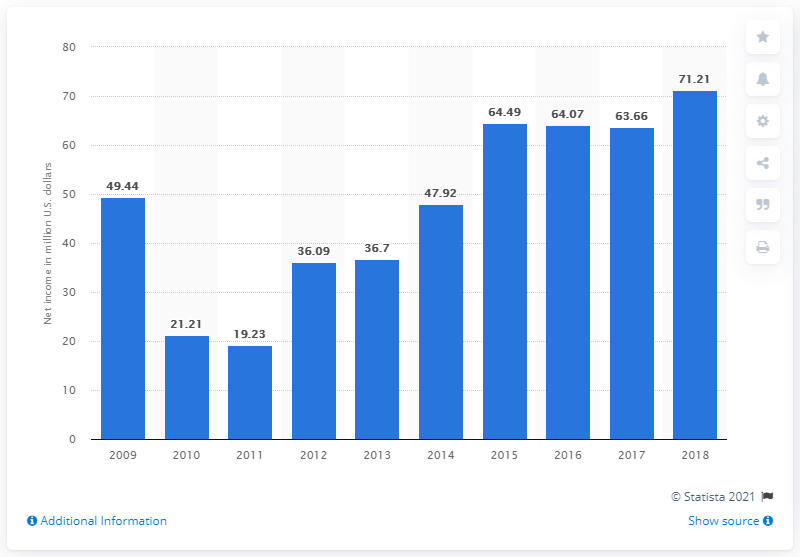Give some essential details in this illustration. Sonic Corp.'s net income in 2018 was $71.21 million. 